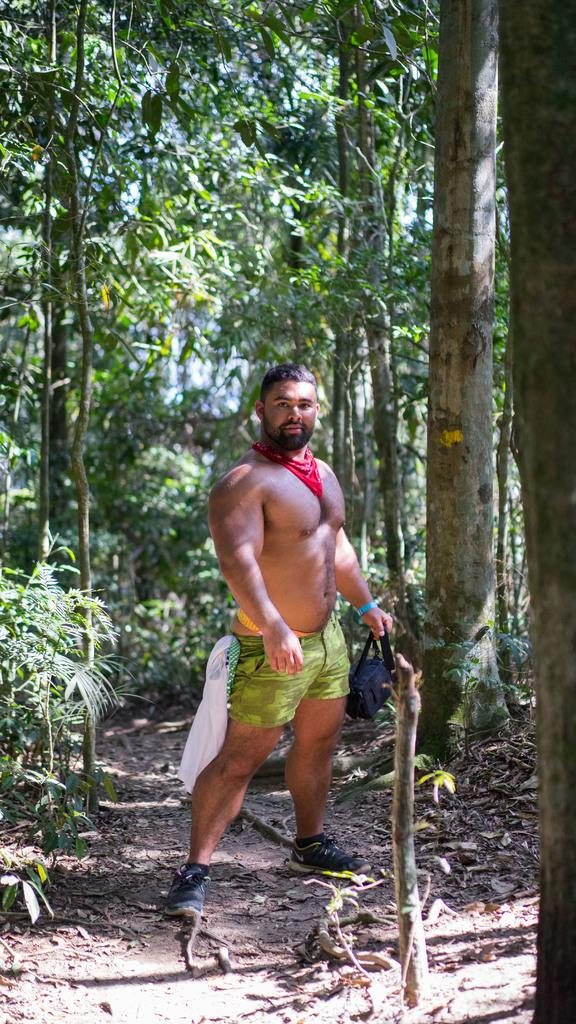What is the main subject of the image? There is a man standing in the center of the image. What is the man holding in the image? The man is holding a bag. What can be seen in the background of the image? There are trees and dry leaves visible in the background of the image. What type of button is the man wearing on his elbow in the image? There is no button or mention of an elbow in the image; the man is simply holding a bag. 